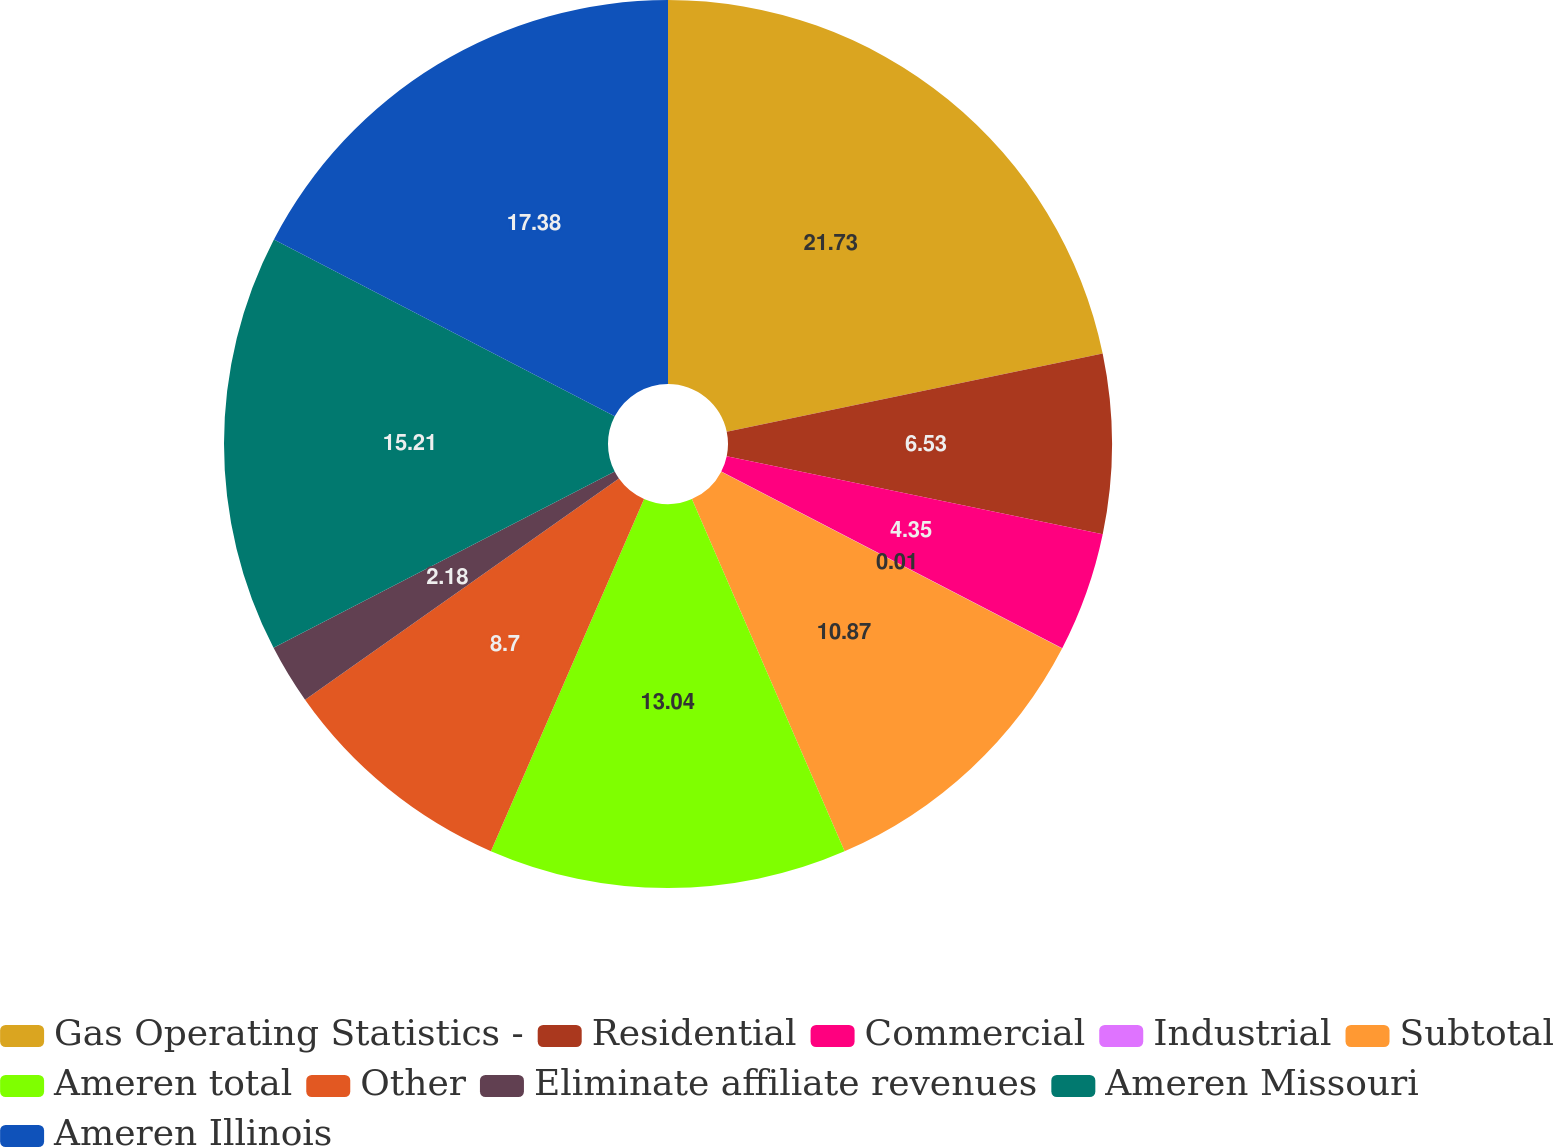Convert chart. <chart><loc_0><loc_0><loc_500><loc_500><pie_chart><fcel>Gas Operating Statistics -<fcel>Residential<fcel>Commercial<fcel>Industrial<fcel>Subtotal<fcel>Ameren total<fcel>Other<fcel>Eliminate affiliate revenues<fcel>Ameren Missouri<fcel>Ameren Illinois<nl><fcel>21.73%<fcel>6.53%<fcel>4.35%<fcel>0.01%<fcel>10.87%<fcel>13.04%<fcel>8.7%<fcel>2.18%<fcel>15.21%<fcel>17.38%<nl></chart> 